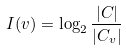<formula> <loc_0><loc_0><loc_500><loc_500>I ( v ) = \log _ { 2 } \frac { | C | } { | C _ { v } | }</formula> 